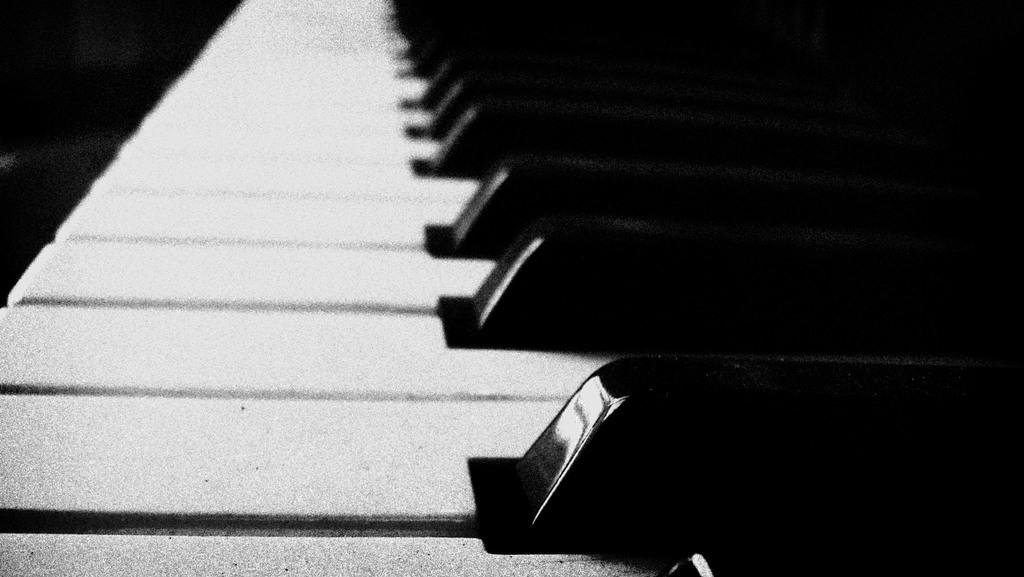What type of musical instrument is depicted in the image? The image features piano keys. What colors are the piano keys? The piano keys are in white and black colors. What is the color scheme of the entire image? The image is black and white. How many fish can be seen swimming near the piano keys in the image? There are no fish present in the image; it features piano keys in a black and white color scheme. 